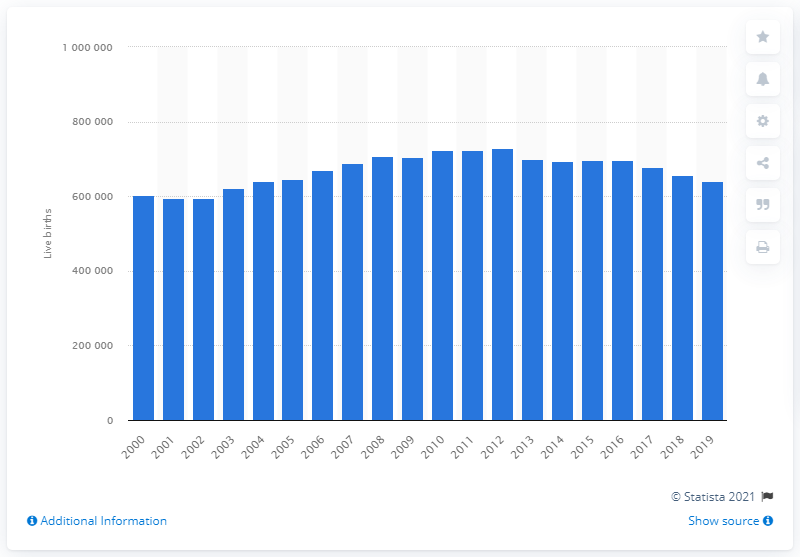Outline some significant characteristics in this image. There were 639,721 live births in England and Wales in the year 2019. 